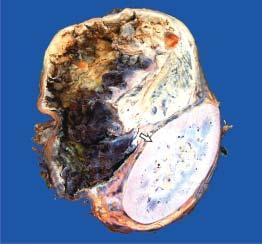what does cut surface of tumour show?
Answer the question using a single word or phrase. Cystic change while solid areas show dark brown 